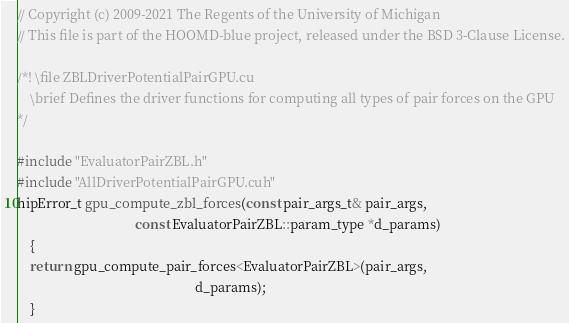<code> <loc_0><loc_0><loc_500><loc_500><_Cuda_>// Copyright (c) 2009-2021 The Regents of the University of Michigan
// This file is part of the HOOMD-blue project, released under the BSD 3-Clause License.

/*! \file ZBLDriverPotentialPairGPU.cu
    \brief Defines the driver functions for computing all types of pair forces on the GPU
*/

#include "EvaluatorPairZBL.h"
#include "AllDriverPotentialPairGPU.cuh"
hipError_t gpu_compute_zbl_forces(const pair_args_t& pair_args,
                                   const EvaluatorPairZBL::param_type *d_params)
    {
    return gpu_compute_pair_forces<EvaluatorPairZBL>(pair_args,
                                                     d_params);
    }

</code> 